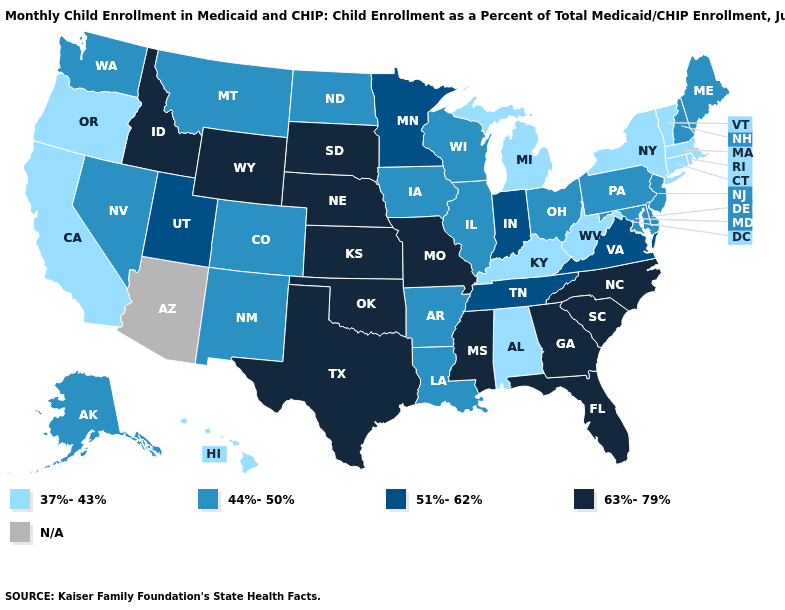How many symbols are there in the legend?
Short answer required. 5. Does the map have missing data?
Write a very short answer. Yes. Does Wyoming have the lowest value in the West?
Give a very brief answer. No. Which states have the lowest value in the Northeast?
Quick response, please. Connecticut, Massachusetts, New York, Rhode Island, Vermont. What is the highest value in the MidWest ?
Be succinct. 63%-79%. What is the value of New Mexico?
Concise answer only. 44%-50%. What is the value of Michigan?
Concise answer only. 37%-43%. Does Mississippi have the highest value in the USA?
Short answer required. Yes. Name the states that have a value in the range 44%-50%?
Concise answer only. Alaska, Arkansas, Colorado, Delaware, Illinois, Iowa, Louisiana, Maine, Maryland, Montana, Nevada, New Hampshire, New Jersey, New Mexico, North Dakota, Ohio, Pennsylvania, Washington, Wisconsin. Name the states that have a value in the range 37%-43%?
Short answer required. Alabama, California, Connecticut, Hawaii, Kentucky, Massachusetts, Michigan, New York, Oregon, Rhode Island, Vermont, West Virginia. What is the lowest value in states that border Colorado?
Write a very short answer. 44%-50%. Among the states that border North Carolina , does South Carolina have the lowest value?
Be succinct. No. Name the states that have a value in the range 44%-50%?
Quick response, please. Alaska, Arkansas, Colorado, Delaware, Illinois, Iowa, Louisiana, Maine, Maryland, Montana, Nevada, New Hampshire, New Jersey, New Mexico, North Dakota, Ohio, Pennsylvania, Washington, Wisconsin. 